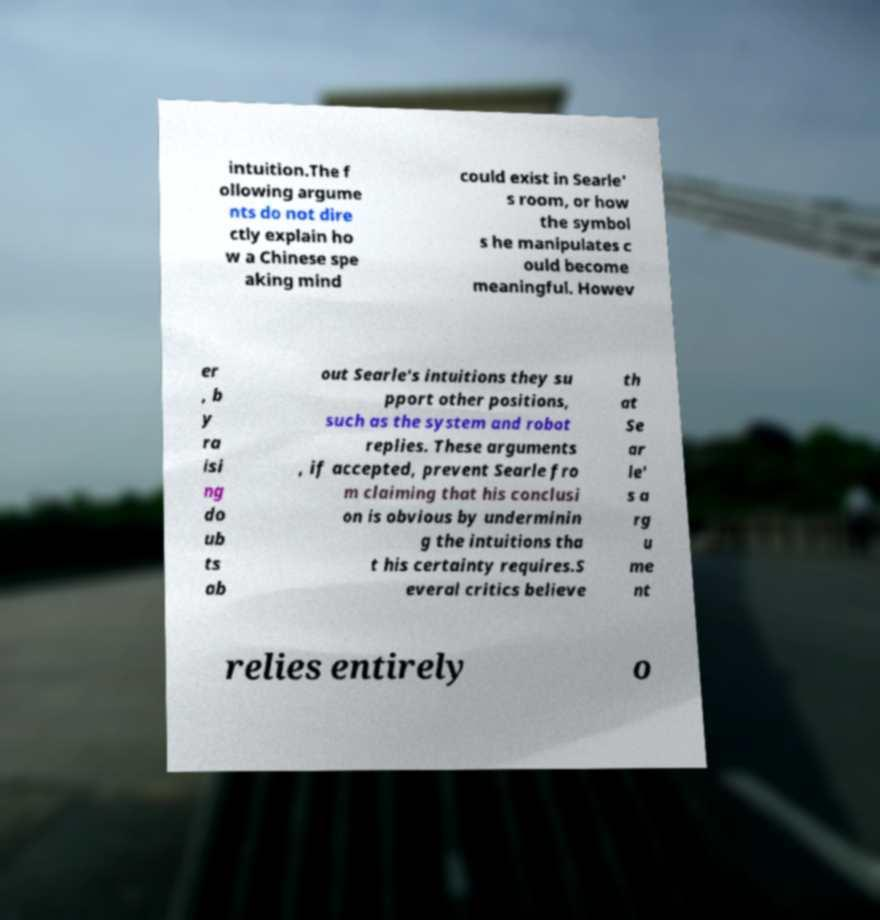Can you read and provide the text displayed in the image?This photo seems to have some interesting text. Can you extract and type it out for me? intuition.The f ollowing argume nts do not dire ctly explain ho w a Chinese spe aking mind could exist in Searle' s room, or how the symbol s he manipulates c ould become meaningful. Howev er , b y ra isi ng do ub ts ab out Searle's intuitions they su pport other positions, such as the system and robot replies. These arguments , if accepted, prevent Searle fro m claiming that his conclusi on is obvious by underminin g the intuitions tha t his certainty requires.S everal critics believe th at Se ar le' s a rg u me nt relies entirely o 